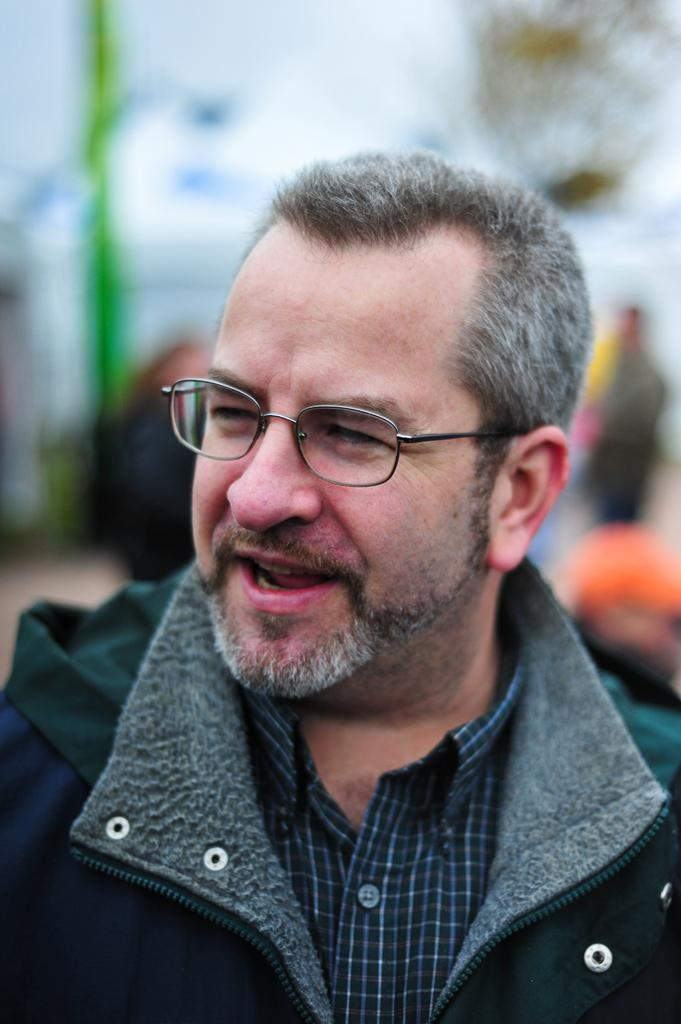What is the main subject of the image? There is a person in the image. Are there any other people visible in the image? Yes, there are other people behind the person. Can you describe the background of the image? The background of the image is blurred. What type of can is being used by the fairies in the image? There are no fairies or cans present in the image. 